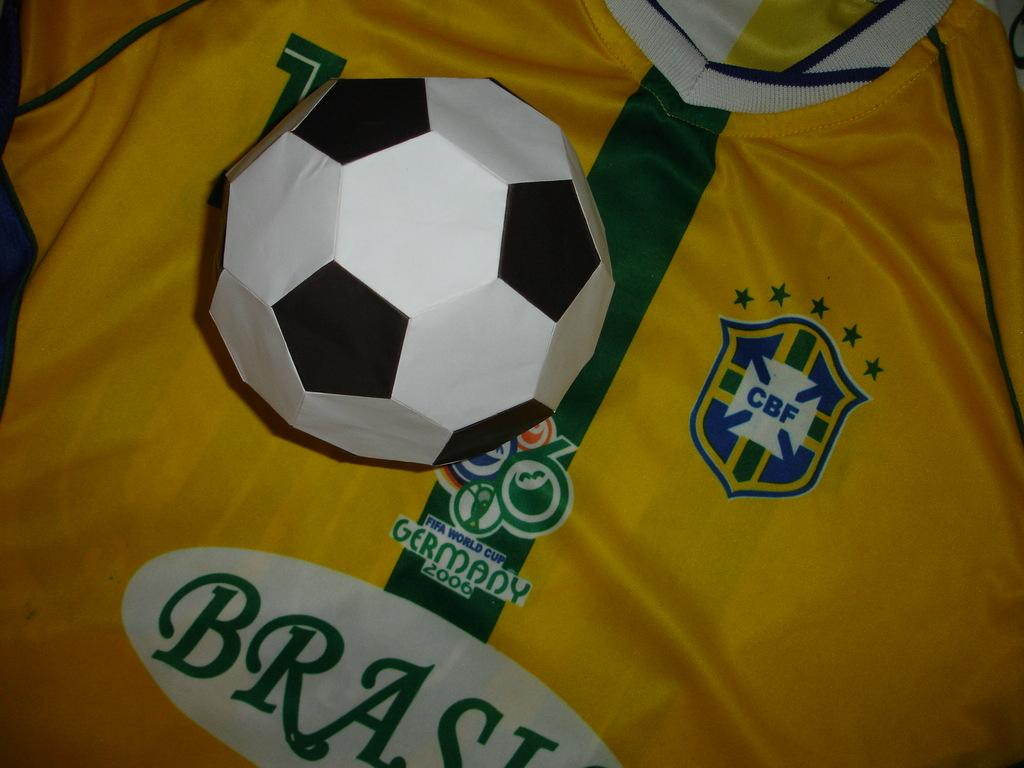<image>
Relay a brief, clear account of the picture shown. A soccer shirt is decorated with a white Brasil oval and a Germany 2006 image. 